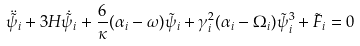Convert formula to latex. <formula><loc_0><loc_0><loc_500><loc_500>\ddot { \tilde { \psi _ { i } } } + 3 H \dot { \tilde { \psi } } _ { i } + \frac { 6 } { \kappa } ( \alpha _ { i } - \omega ) \tilde { \psi } _ { i } + \gamma _ { i } ^ { 2 } ( \alpha _ { i } - \Omega _ { i } ) { \tilde { \psi } _ { i } } ^ { 3 } + \tilde { F } _ { i } = 0</formula> 